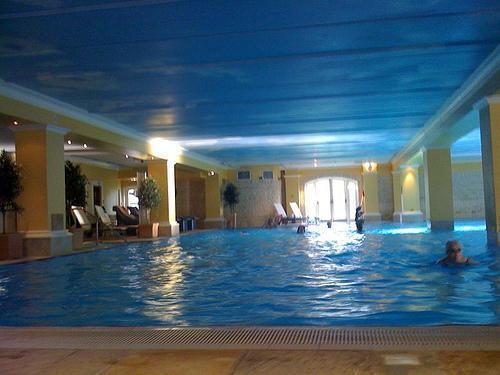How many plants are see in this photo?
Give a very brief answer. 4. How many chairs are seen in this photo?
Give a very brief answer. 6. How many vents are in this photo?
Give a very brief answer. 2. How many ceiling lights are in this photo?
Give a very brief answer. 9. How many people?
Give a very brief answer. 4. 